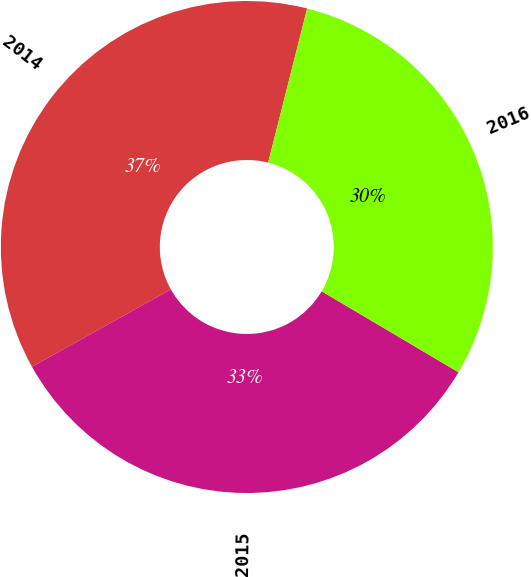<chart> <loc_0><loc_0><loc_500><loc_500><pie_chart><fcel>2014<fcel>2015<fcel>2016<nl><fcel>37.04%<fcel>33.4%<fcel>29.56%<nl></chart> 